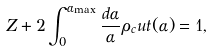Convert formula to latex. <formula><loc_0><loc_0><loc_500><loc_500>Z + 2 \int _ { 0 } ^ { \alpha _ { \max } } \frac { d \alpha } { \alpha } \rho _ { c } u t ( \alpha ) = 1 ,</formula> 